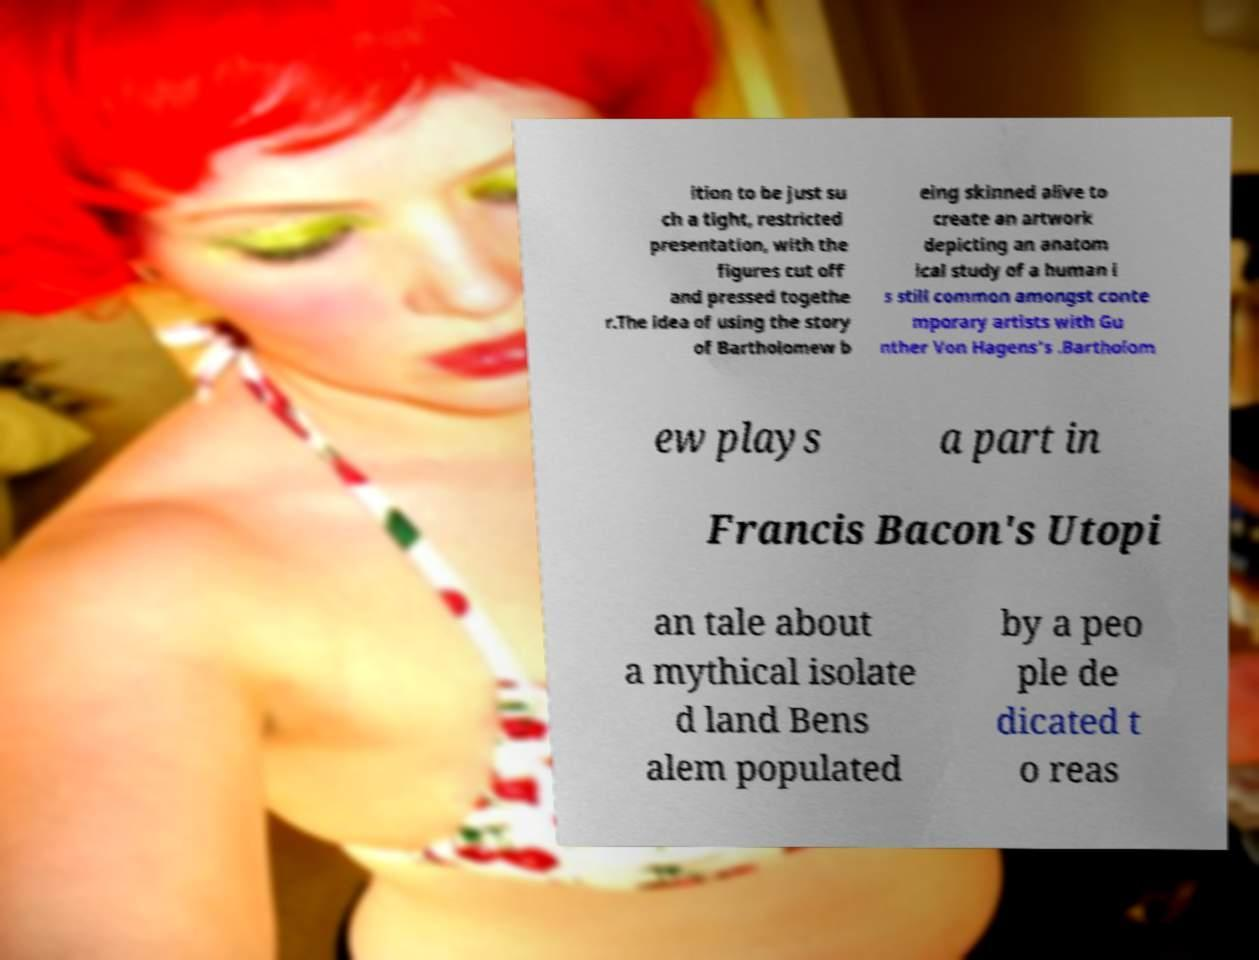For documentation purposes, I need the text within this image transcribed. Could you provide that? ition to be just su ch a tight, restricted presentation, with the figures cut off and pressed togethe r.The idea of using the story of Bartholomew b eing skinned alive to create an artwork depicting an anatom ical study of a human i s still common amongst conte mporary artists with Gu nther Von Hagens's .Bartholom ew plays a part in Francis Bacon's Utopi an tale about a mythical isolate d land Bens alem populated by a peo ple de dicated t o reas 